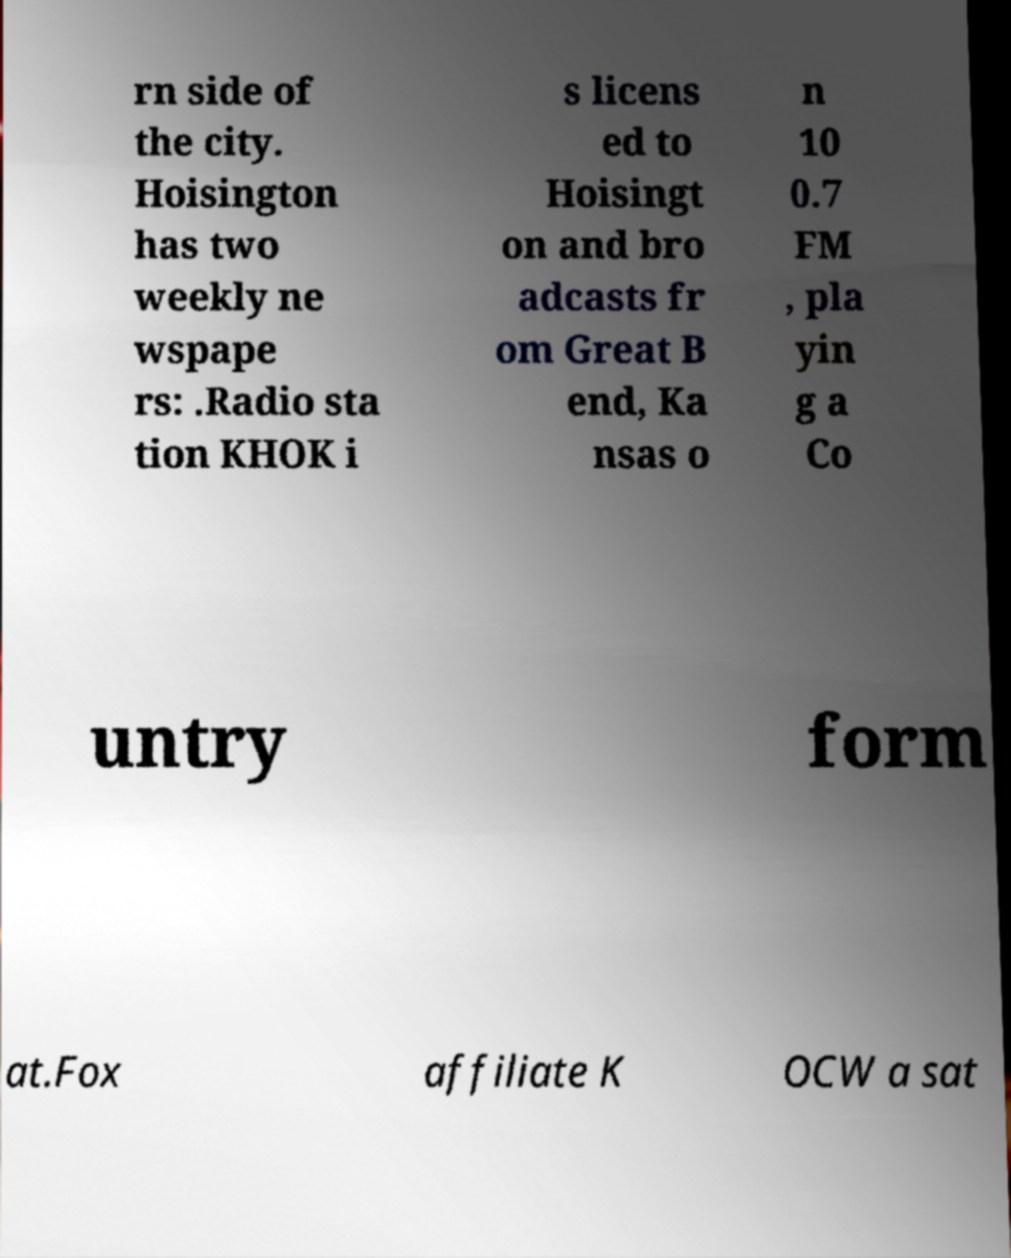Could you assist in decoding the text presented in this image and type it out clearly? rn side of the city. Hoisington has two weekly ne wspape rs: .Radio sta tion KHOK i s licens ed to Hoisingt on and bro adcasts fr om Great B end, Ka nsas o n 10 0.7 FM , pla yin g a Co untry form at.Fox affiliate K OCW a sat 